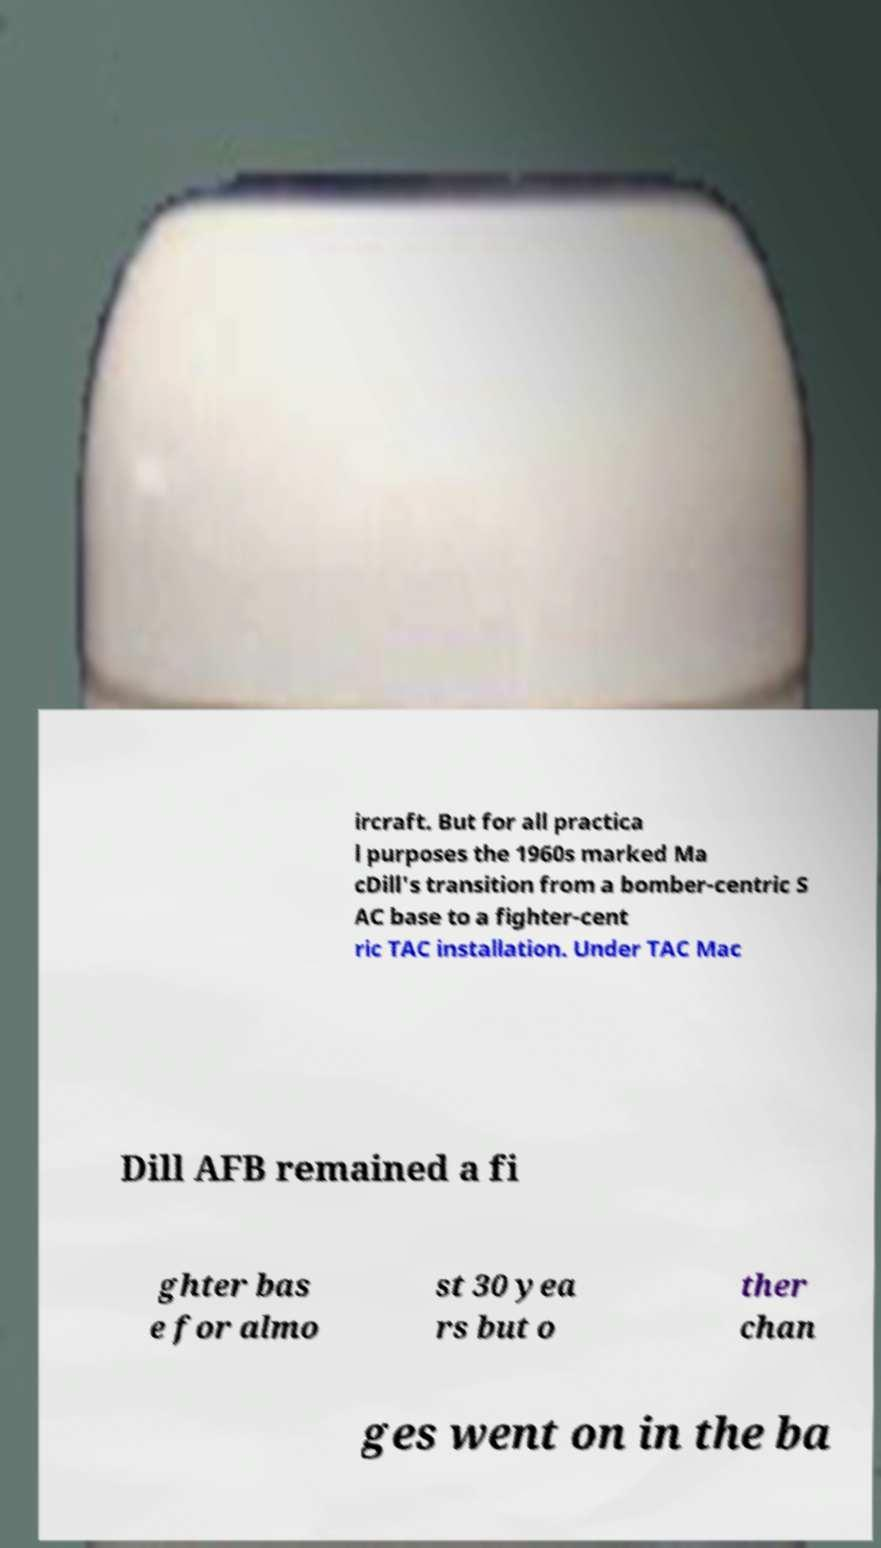I need the written content from this picture converted into text. Can you do that? ircraft. But for all practica l purposes the 1960s marked Ma cDill's transition from a bomber-centric S AC base to a fighter-cent ric TAC installation. Under TAC Mac Dill AFB remained a fi ghter bas e for almo st 30 yea rs but o ther chan ges went on in the ba 